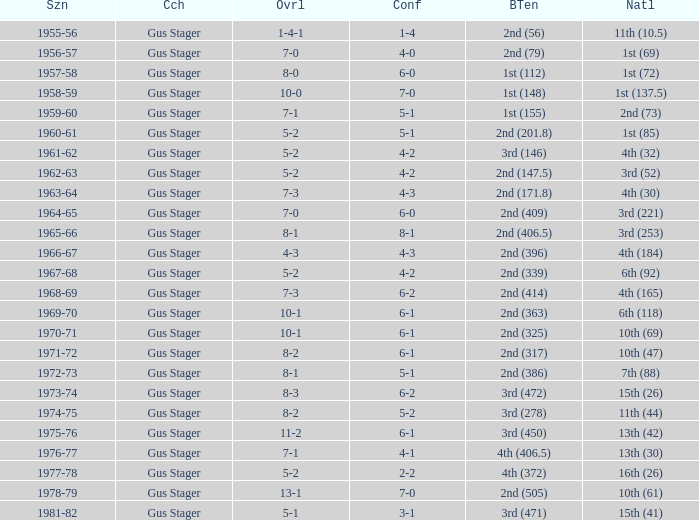What is the Coach with a Big Ten that is 1st (148)? Gus Stager. 